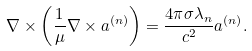<formula> <loc_0><loc_0><loc_500><loc_500>\nabla \times \left ( \frac { 1 } { \mu } \nabla \times { a } ^ { ( n ) } \right ) = \frac { 4 \pi \sigma \lambda _ { n } } { c ^ { 2 } } { a } ^ { ( n ) } .</formula> 